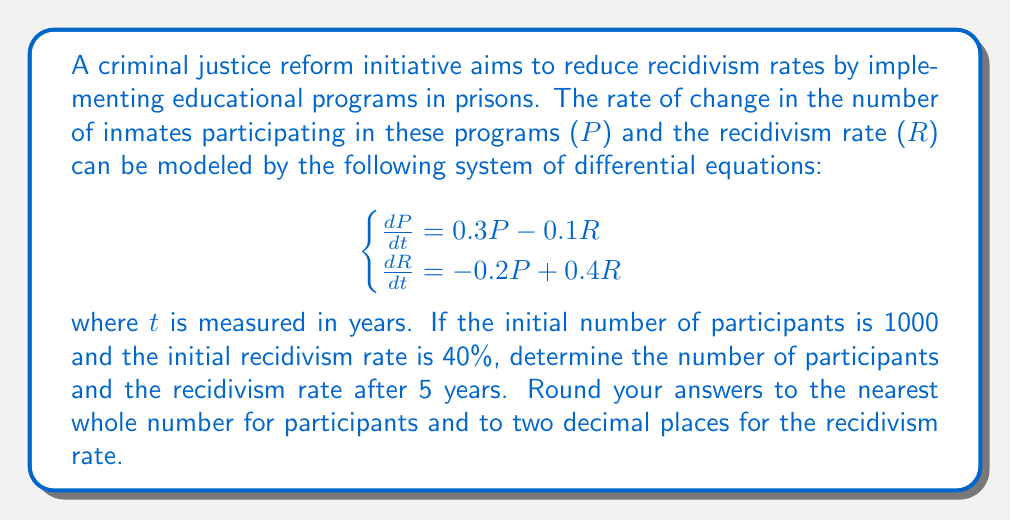Can you solve this math problem? To solve this system of second-order linear differential equations, we need to follow these steps:

1) First, we need to find the eigenvalues of the coefficient matrix:

   $$A = \begin{pmatrix}
   0.3 & -0.1 \\
   -0.2 & 0.4
   \end{pmatrix}$$

2) The characteristic equation is:
   
   $$\det(A - \lambda I) = \begin{vmatrix}
   0.3 - \lambda & -0.1 \\
   -0.2 & 0.4 - \lambda
   \end{vmatrix} = (0.3 - \lambda)(0.4 - \lambda) + 0.02 = \lambda^2 - 0.7\lambda + 0.1 = 0$$

3) Solving this quadratic equation:
   
   $$\lambda = \frac{0.7 \pm \sqrt{0.49 - 0.4}}{2} = \frac{0.7 \pm 0.3}{2}$$

   So, $\lambda_1 = 0.5$ and $\lambda_2 = 0.2$

4) Now, we find the eigenvectors for each eigenvalue:

   For $\lambda_1 = 0.5$:
   $$(A - 0.5I)\vec{v_1} = \vec{0}$$
   $$\begin{pmatrix}
   -0.2 & -0.1 \\
   -0.2 & -0.1
   \end{pmatrix}\vec{v_1} = \vec{0}$$

   This gives us $\vec{v_1} = (1, 2)$

   For $\lambda_2 = 0.2$:
   $$(A - 0.2I)\vec{v_2} = \vec{0}$$
   $$\begin{pmatrix}
   0.1 & -0.1 \\
   -0.2 & 0.2
   \end{pmatrix}\vec{v_2} = \vec{0}$$

   This gives us $\vec{v_2} = (1, 1)$

5) The general solution is:

   $$\begin{pmatrix}
   P(t) \\
   R(t)
   \end{pmatrix} = c_1e^{0.5t}\begin{pmatrix}
   1 \\
   2
   \end{pmatrix} + c_2e^{0.2t}\begin{pmatrix}
   1 \\
   1
   \end{pmatrix}$$

6) Using the initial conditions $P(0) = 1000$ and $R(0) = 40$, we can find $c_1$ and $c_2$:

   $$1000 = c_1 + c_2$$
   $$40 = 2c_1 + c_2$$

   Solving this system gives us $c_1 = -960$ and $c_2 = 1960$

7) Therefore, the solution is:

   $$\begin{pmatrix}
   P(t) \\
   R(t)
   \end{pmatrix} = -960e^{0.5t}\begin{pmatrix}
   1 \\
   2
   \end{pmatrix} + 1960e^{0.2t}\begin{pmatrix}
   1 \\
   1
   \end{pmatrix}$$

8) After 5 years, $t = 5$:

   $$P(5) = -960e^{2.5} + 1960e^{1} \approx 2687$$
   $$R(5) = -1920e^{2.5} + 1960e^{1} \approx 21.85\%$$
Answer: After 5 years, the number of participants will be approximately 2687, and the recidivism rate will be approximately 21.85%. 